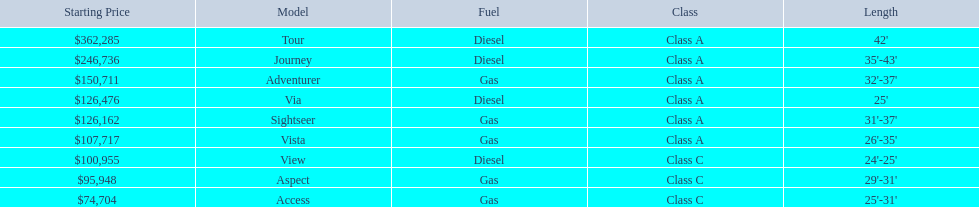Which models of winnebago are there? Tour, Journey, Adventurer, Via, Sightseer, Vista, View, Aspect, Access. Which ones are diesel? Tour, Journey, Sightseer, View. Which of those is the longest? Tour, Journey. Which one has the highest starting price? Tour. 